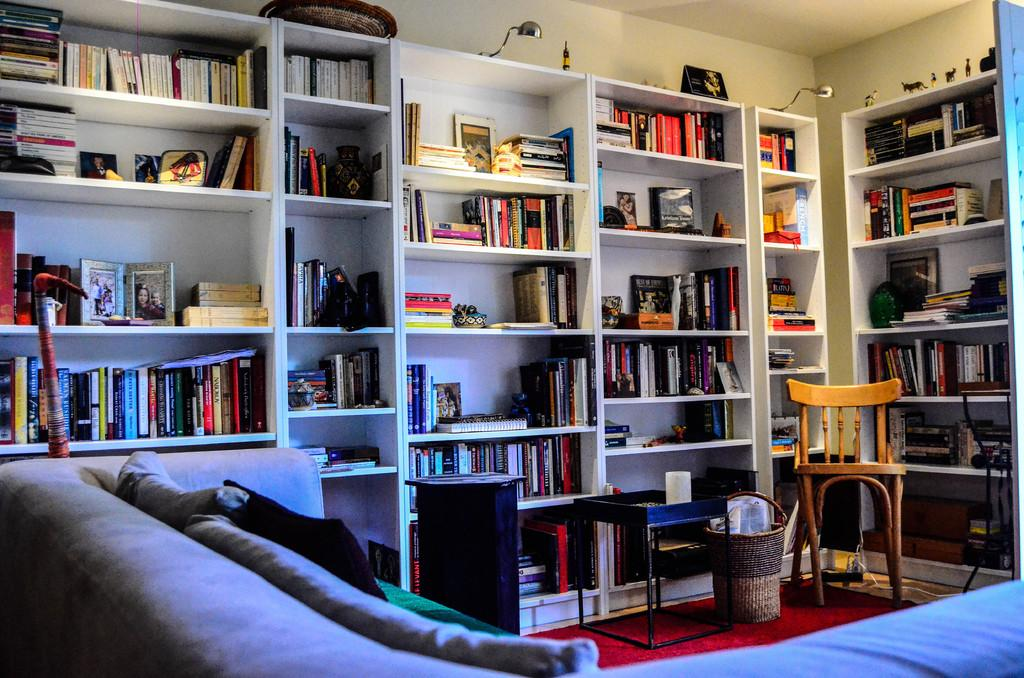What type of furniture is present in the image? There is a book rack, a couch, a pillow, and a chair in the image. Can you describe the seating arrangement in the image? The couch and chair provide seating options, while the pillow can be used for additional comfort. Where is the book rack located in the image? The book rack is in the image, but its exact location is not specified. What type of insect can be seen crawling on the book rack in the image? There is no insect present on the book rack in the image. What type of journey is depicted in the image? The image does not depict a journey; it shows furniture items in a room. 